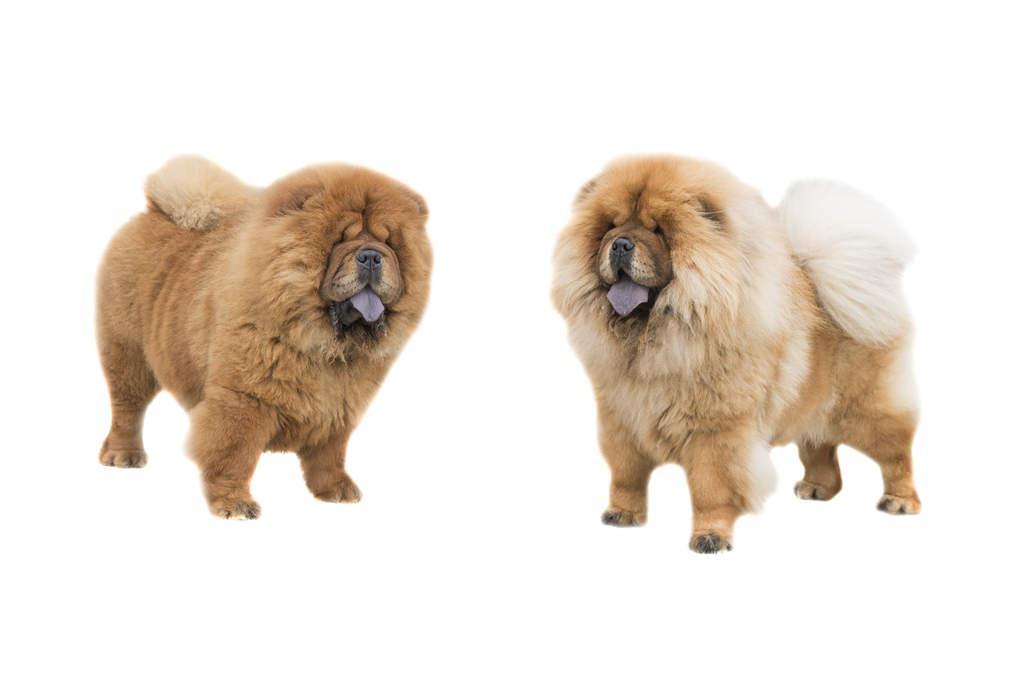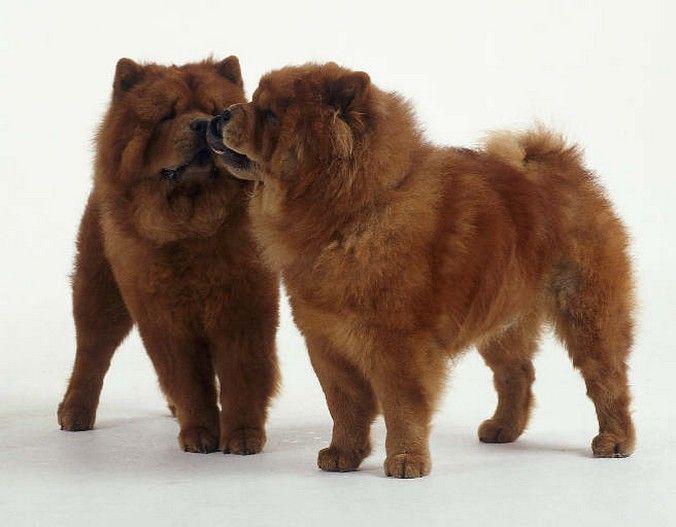The first image is the image on the left, the second image is the image on the right. For the images shown, is this caption "There are two dogs in the right image." true? Answer yes or no. Yes. The first image is the image on the left, the second image is the image on the right. For the images shown, is this caption "Each image contains the same number of dogs, the left image includes a dog with its blue tongue out, and at least one image features a dog in a standing pose." true? Answer yes or no. Yes. 